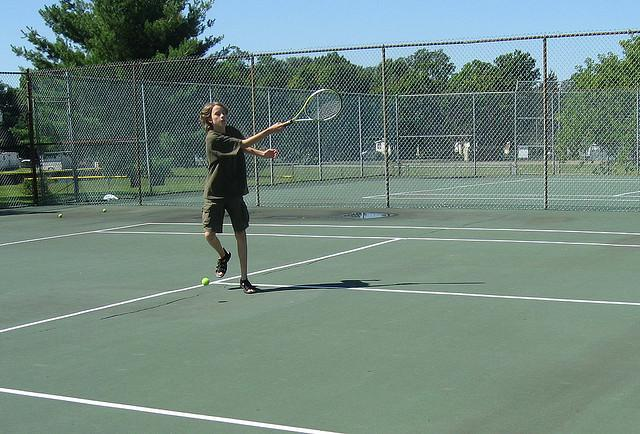What did the boy most likely just do to the ball with his racket? hit it 